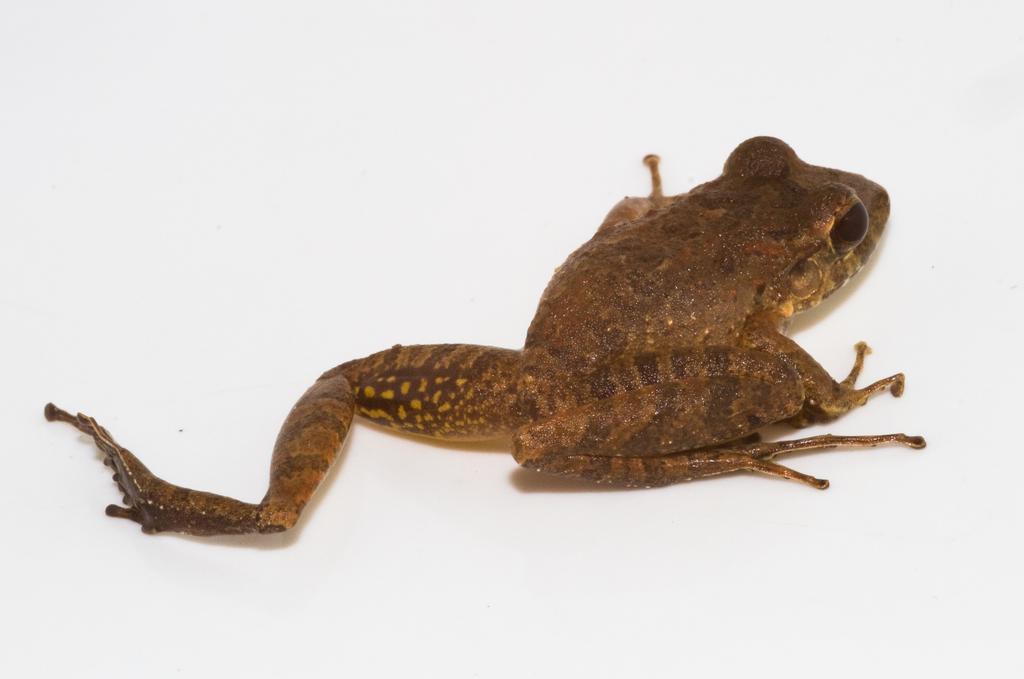Describe this image in one or two sentences. In this image I can see the frog which is in brown color. It is on the white color surface. 